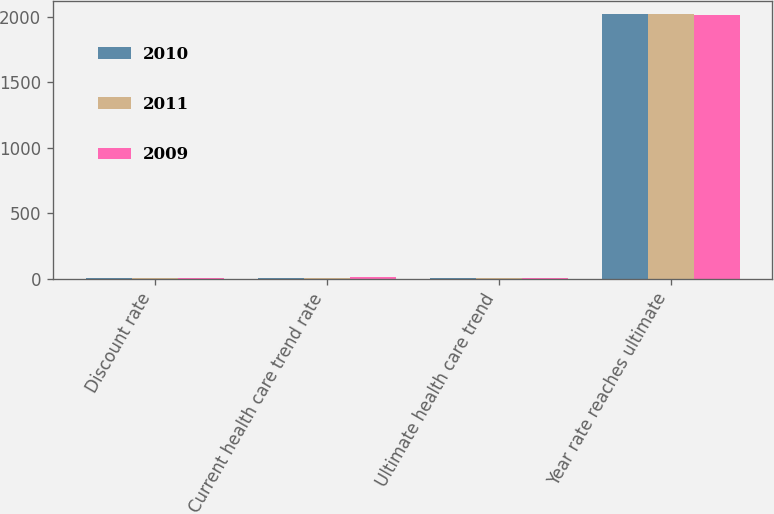Convert chart. <chart><loc_0><loc_0><loc_500><loc_500><stacked_bar_chart><ecel><fcel>Discount rate<fcel>Current health care trend rate<fcel>Ultimate health care trend<fcel>Year rate reaches ultimate<nl><fcel>2010<fcel>5.75<fcel>8.7<fcel>5<fcel>2023<nl><fcel>2011<fcel>5.5<fcel>9<fcel>5<fcel>2023<nl><fcel>2009<fcel>6.25<fcel>10<fcel>6<fcel>2017<nl></chart> 